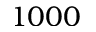Convert formula to latex. <formula><loc_0><loc_0><loc_500><loc_500>1 0 0 0</formula> 